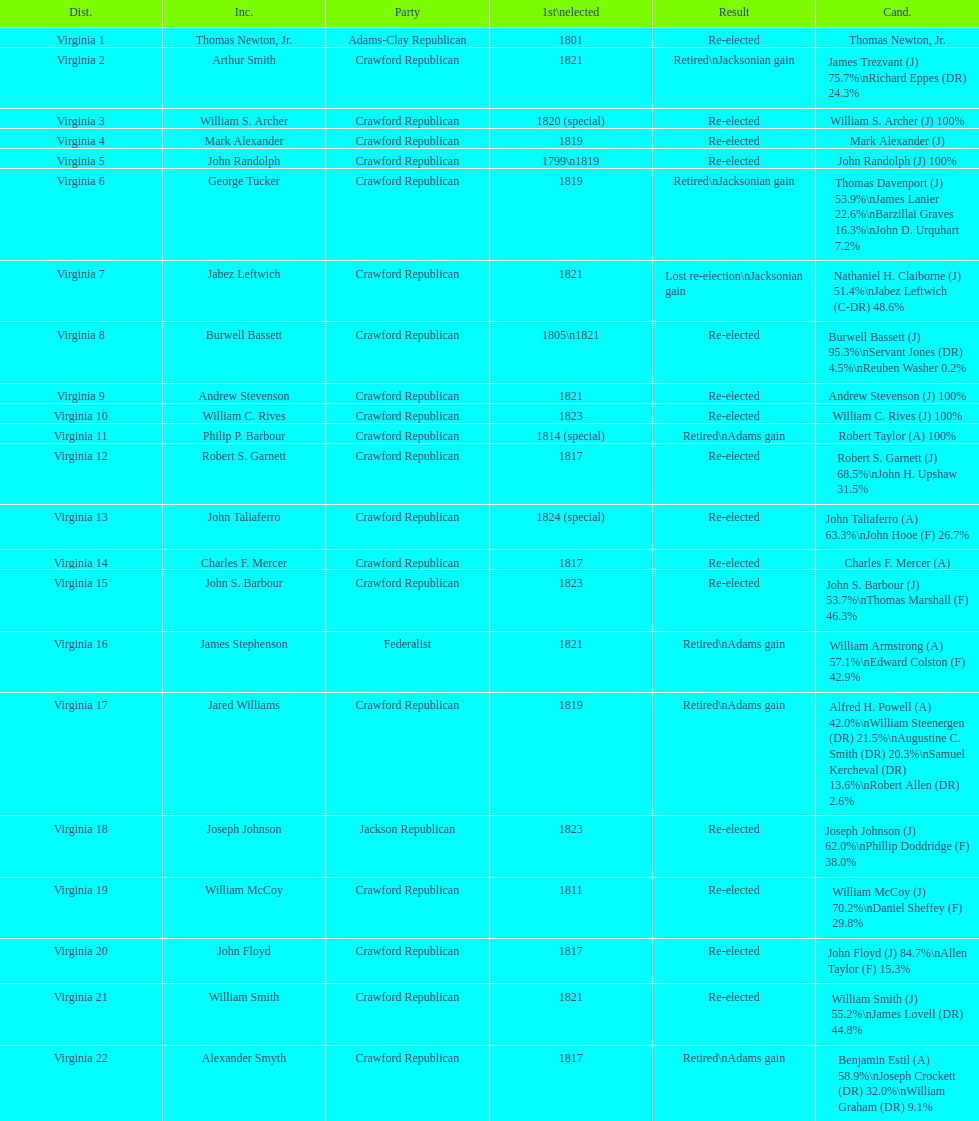How many districts are there in virginia? 22. 